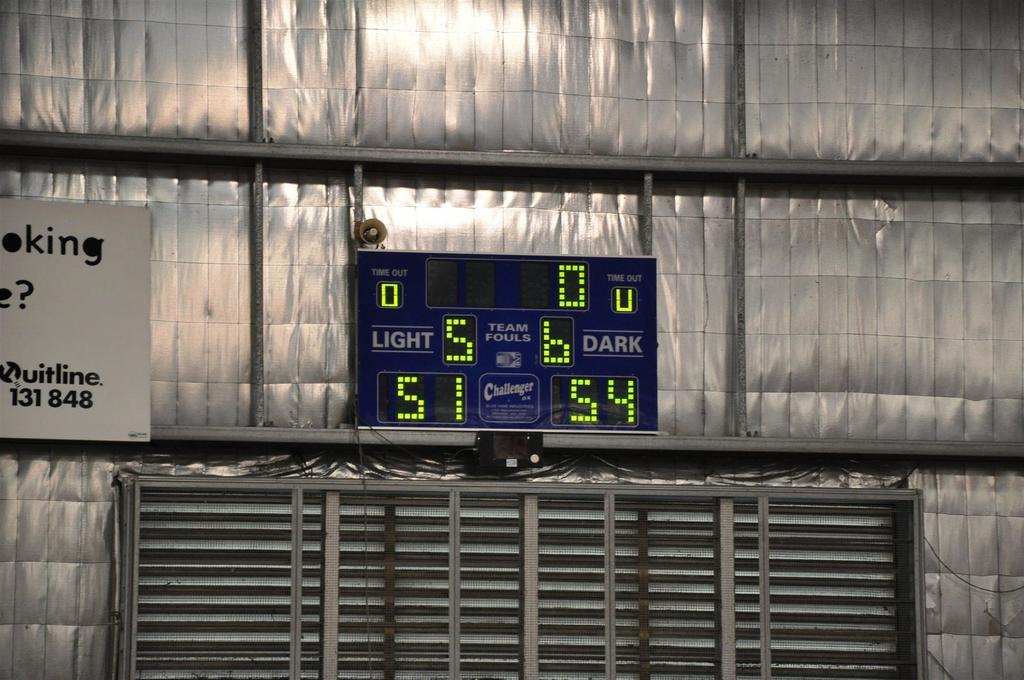Provide a one-sentence caption for the provided image. A scoreboard shows the score of teams as 51 and 54. 